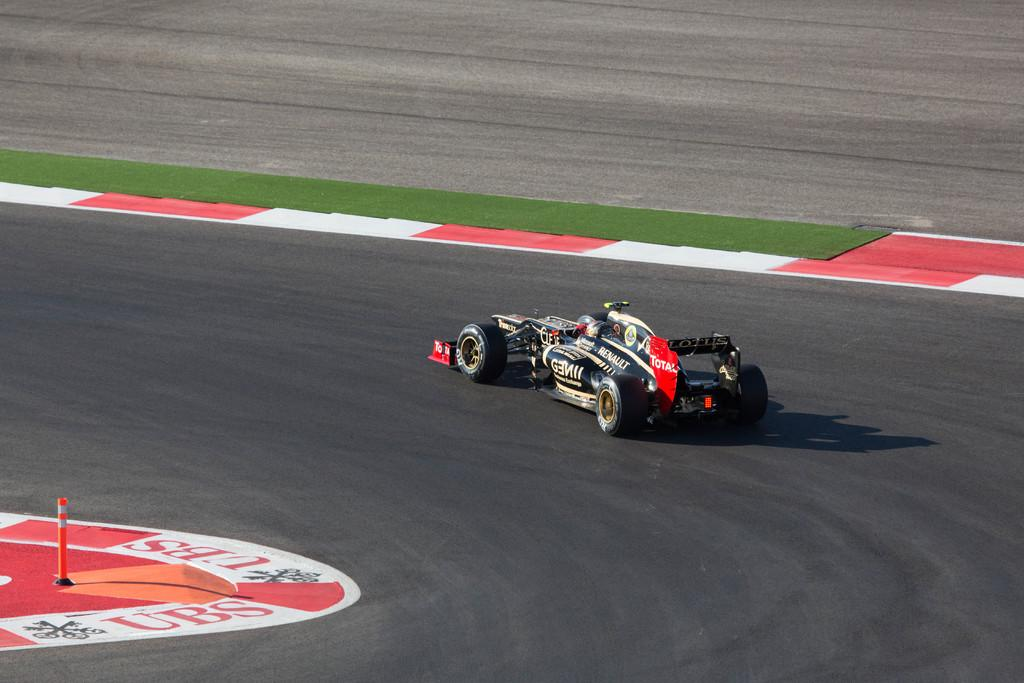What is the main subject of the image? The main subject of the image is a car on the road. What can be seen on the left side of the image? There is a safety pole on the left side of the image. What type of vegetation is present in the image? There is grass at the center of the image. How many apples are on the car in the image? There are no apples present in the image. What type of fruit is the porter carrying in the image? There is no porter or fruit present in the image. 